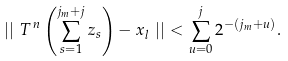<formula> <loc_0><loc_0><loc_500><loc_500>\left | \right | \, T ^ { \, n } \left ( \sum _ { s = 1 } ^ { j _ { m } + j } z _ { s } \right ) - x _ { l } \, \left | \right | < \sum _ { u = 0 } ^ { j } 2 ^ { - ( j _ { m } + u ) } .</formula> 